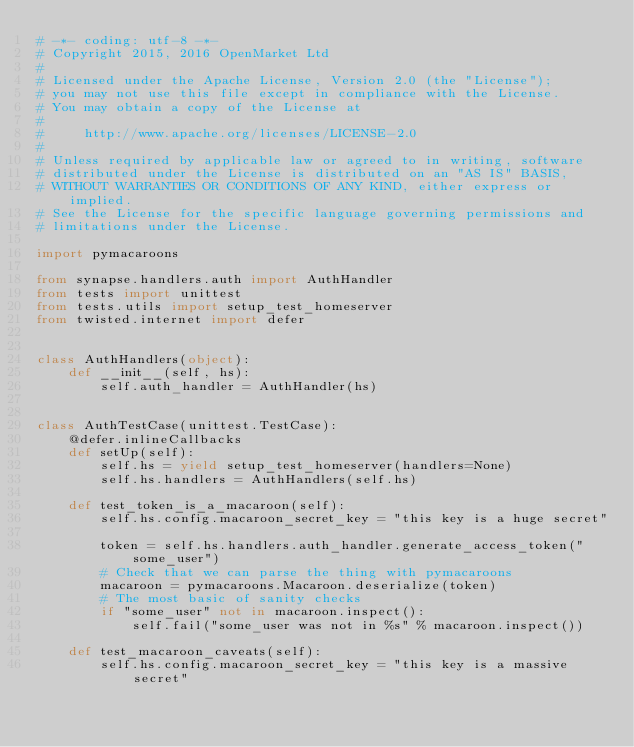Convert code to text. <code><loc_0><loc_0><loc_500><loc_500><_Python_># -*- coding: utf-8 -*-
# Copyright 2015, 2016 OpenMarket Ltd
#
# Licensed under the Apache License, Version 2.0 (the "License");
# you may not use this file except in compliance with the License.
# You may obtain a copy of the License at
#
#     http://www.apache.org/licenses/LICENSE-2.0
#
# Unless required by applicable law or agreed to in writing, software
# distributed under the License is distributed on an "AS IS" BASIS,
# WITHOUT WARRANTIES OR CONDITIONS OF ANY KIND, either express or implied.
# See the License for the specific language governing permissions and
# limitations under the License.

import pymacaroons

from synapse.handlers.auth import AuthHandler
from tests import unittest
from tests.utils import setup_test_homeserver
from twisted.internet import defer


class AuthHandlers(object):
    def __init__(self, hs):
        self.auth_handler = AuthHandler(hs)


class AuthTestCase(unittest.TestCase):
    @defer.inlineCallbacks
    def setUp(self):
        self.hs = yield setup_test_homeserver(handlers=None)
        self.hs.handlers = AuthHandlers(self.hs)

    def test_token_is_a_macaroon(self):
        self.hs.config.macaroon_secret_key = "this key is a huge secret"

        token = self.hs.handlers.auth_handler.generate_access_token("some_user")
        # Check that we can parse the thing with pymacaroons
        macaroon = pymacaroons.Macaroon.deserialize(token)
        # The most basic of sanity checks
        if "some_user" not in macaroon.inspect():
            self.fail("some_user was not in %s" % macaroon.inspect())

    def test_macaroon_caveats(self):
        self.hs.config.macaroon_secret_key = "this key is a massive secret"</code> 